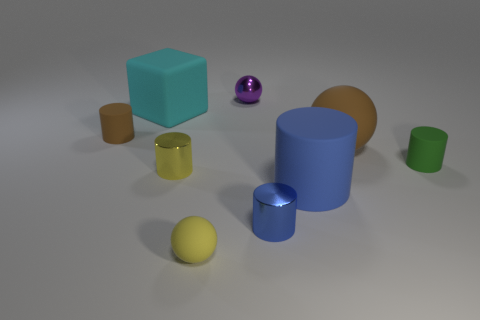Subtract 2 cylinders. How many cylinders are left? 3 Subtract all tiny green cylinders. How many cylinders are left? 4 Subtract all yellow cylinders. How many cylinders are left? 4 Subtract all purple cylinders. Subtract all purple balls. How many cylinders are left? 5 Add 1 metal cylinders. How many objects exist? 10 Subtract all cylinders. How many objects are left? 4 Subtract all small matte spheres. Subtract all matte cubes. How many objects are left? 7 Add 8 tiny blue cylinders. How many tiny blue cylinders are left? 9 Add 6 tiny metal cylinders. How many tiny metal cylinders exist? 8 Subtract 1 brown balls. How many objects are left? 8 